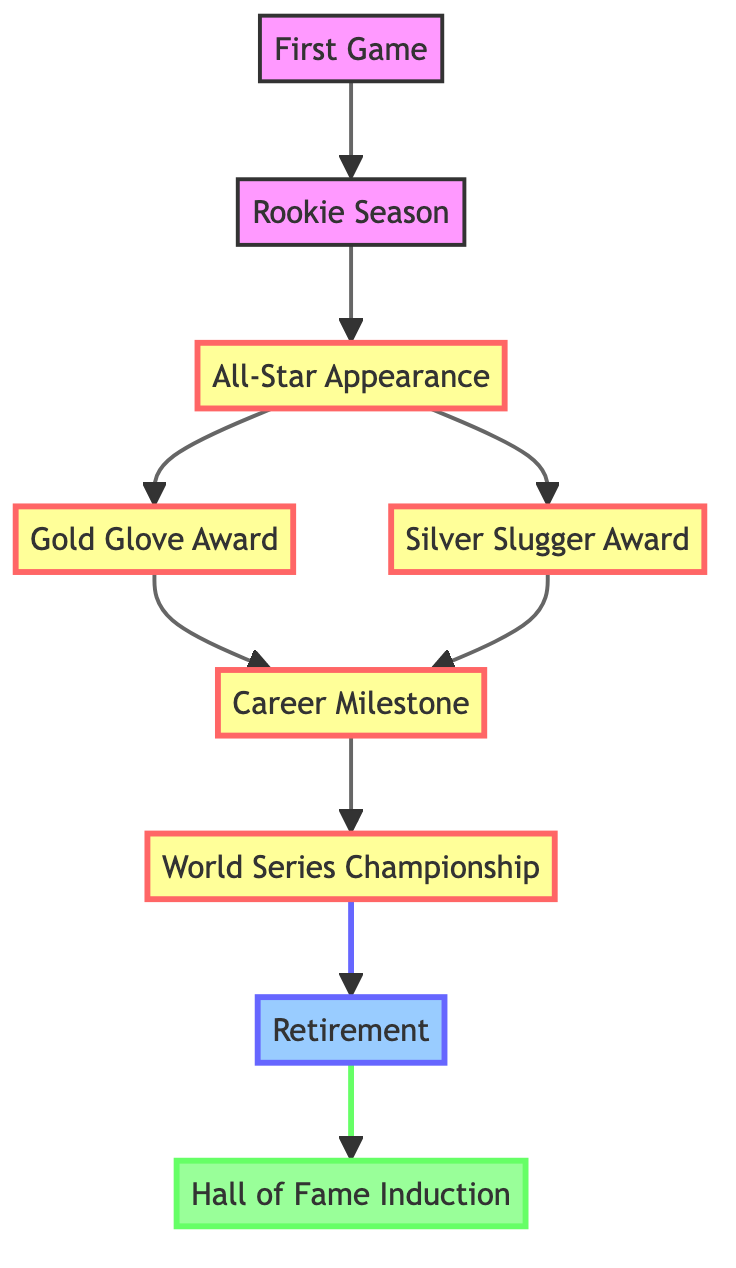What is the first event in the career timeline? The first node in the diagram is labeled "First Game," indicating it is the initial event in the career timeline of Cuban-American baseball players.
Answer: First Game How many major milestones are highlighted in the diagram? By counting the milestone nodes, we observe that there are four major milestones indicated: All-Star Appearance, Gold Glove Award, Silver Slugger Award, and World Series Championship.
Answer: 4 What event follows the Rookie Season? The arrow in the diagram points from "Rookie Season" to "All-Star Appearance," indicating that an All-Star Appearance follows the Rookie Season.
Answer: All-Star Appearance Which award is linked directly from Gold Glove? After the Gold Glove Award, the next node in the diagram is labeled "Career Milestone," which shows it is the event linked directly from Gold Glove.
Answer: Career Milestone What is the last event before Hall of Fame Induction? The diagram shows that "Retirement" is the event directly before "Hall of Fame Induction," making it the final event before induction into the Hall of Fame.
Answer: Retirement What type of award is the Silver Slugger? The diagram categorizes the Silver Slugger Award as a milestone, specifically noting it under the section for career awards.
Answer: Milestone Which event might indicate a player's highest achievement? The diagram signifies that "World Series Championship" is a significant milestone in a player's career, likely representing one of their highest achievements.
Answer: World Series Championship What is the purpose of the arrows in the diagram? The arrows indicate the progression through the career timeline of Cuban-American baseball players, showing the order of events from the first game to potential induction into the Hall of Fame.
Answer: Indicate progression What milestone precedes the World Series Championship? The diagram illustrates that "Career Milestone" comes right before "World Series Championship," indicating that this milestone is a prerequisite before achieving the championship.
Answer: Career Milestone 